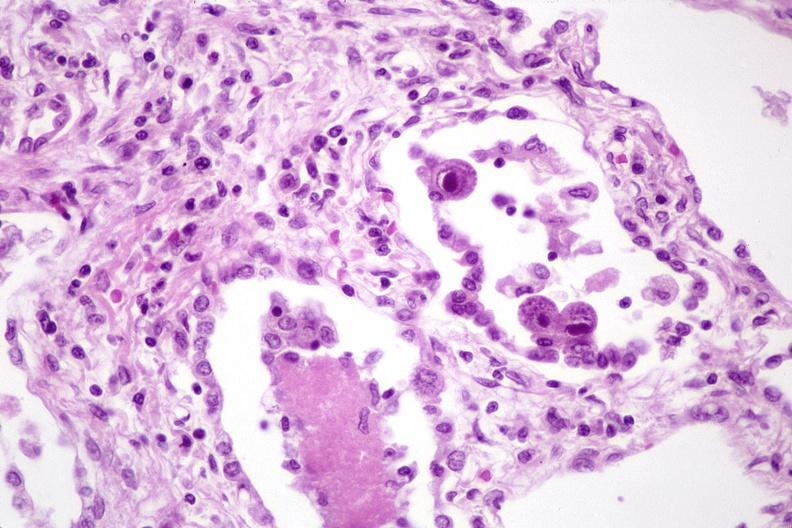what does this image show?
Answer the question using a single word or phrase. Lung 